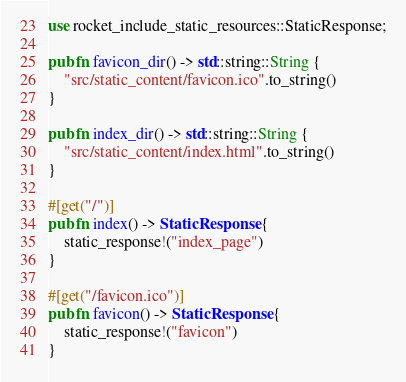<code> <loc_0><loc_0><loc_500><loc_500><_Rust_>use rocket_include_static_resources::StaticResponse;

pub fn favicon_dir() -> std::string::String {
    "src/static_content/favicon.ico".to_string()
}

pub fn index_dir() -> std::string::String {
    "src/static_content/index.html".to_string()
}

#[get("/")]
pub fn index() -> StaticResponse {
    static_response!("index_page")
}

#[get("/favicon.ico")]
pub fn favicon() -> StaticResponse {
    static_response!("favicon")
}
</code> 